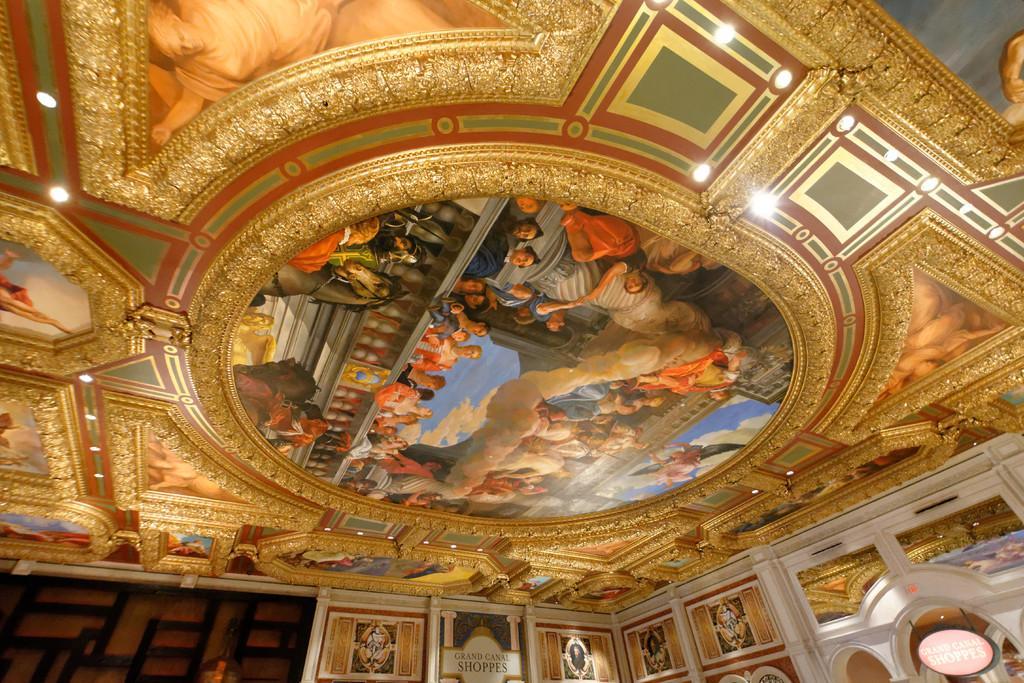Could you give a brief overview of what you see in this image? In this image there is a ceiling. There are picture frames, paintings and lights to the ceiling. In the center there is a painting. In the painting there are many people. Behind them there is the sky. At the bottom of the image there is a wall. There picture frames and paintings on the wall. In the bottom right there is a board with text hanging on the wall. 